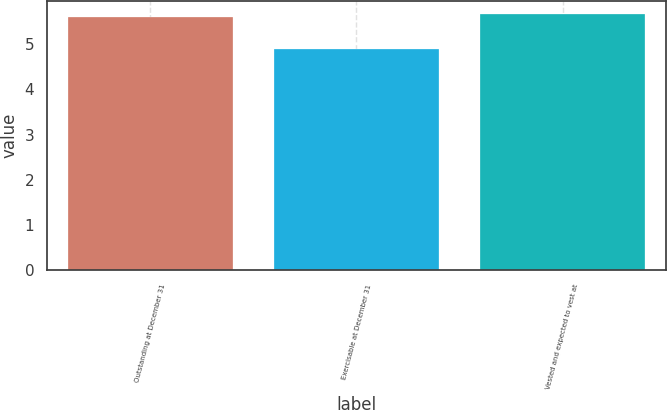Convert chart to OTSL. <chart><loc_0><loc_0><loc_500><loc_500><bar_chart><fcel>Outstanding at December 31<fcel>Exercisable at December 31<fcel>Vested and expected to vest at<nl><fcel>5.6<fcel>4.9<fcel>5.67<nl></chart> 